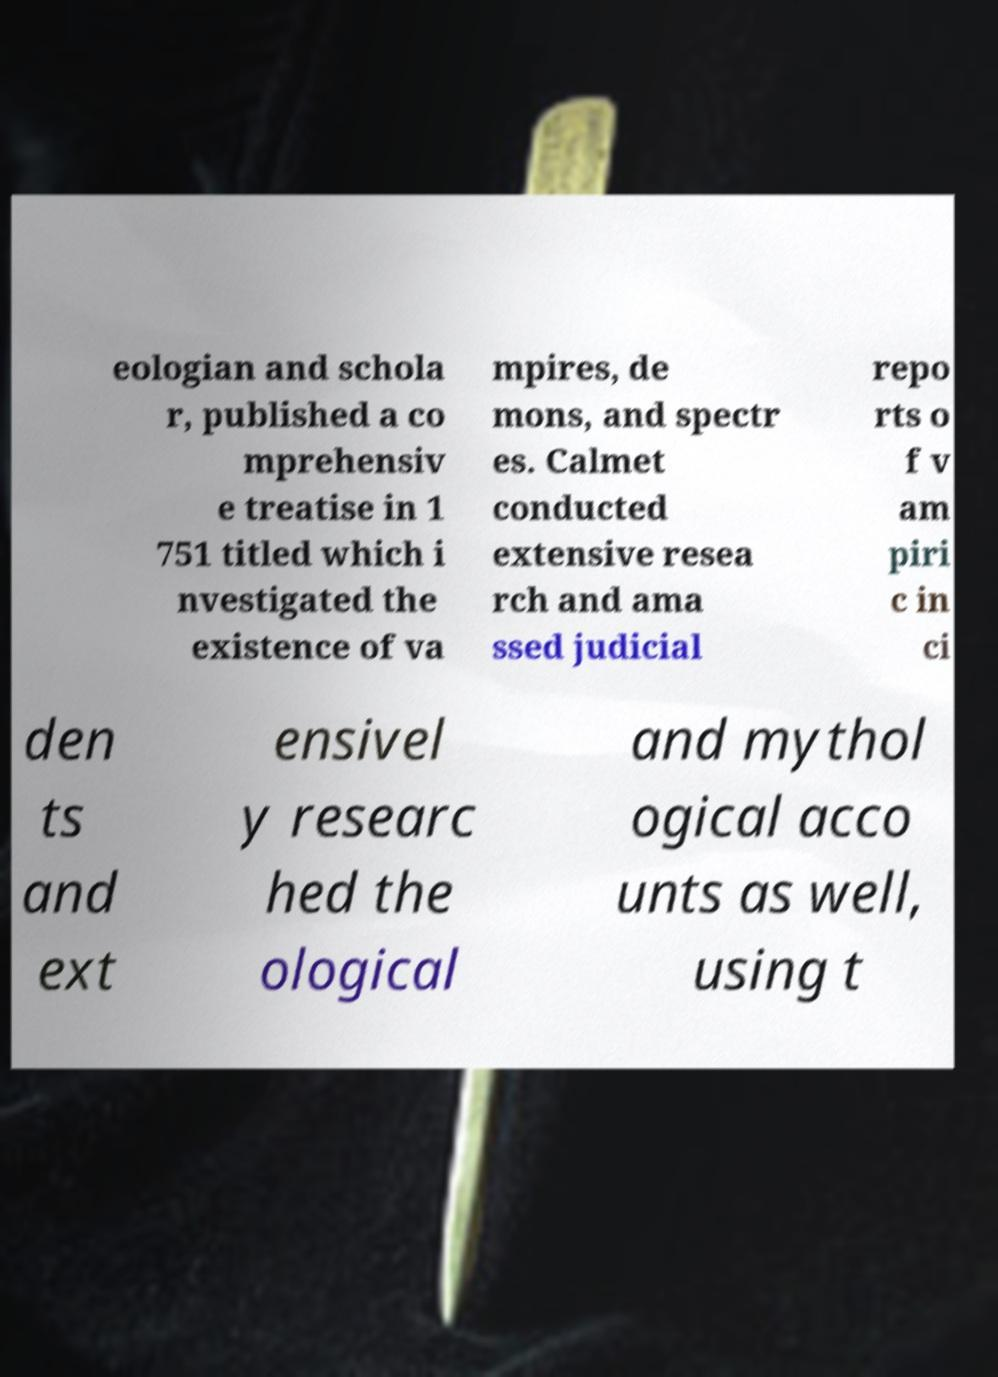Please read and relay the text visible in this image. What does it say? eologian and schola r, published a co mprehensiv e treatise in 1 751 titled which i nvestigated the existence of va mpires, de mons, and spectr es. Calmet conducted extensive resea rch and ama ssed judicial repo rts o f v am piri c in ci den ts and ext ensivel y researc hed the ological and mythol ogical acco unts as well, using t 